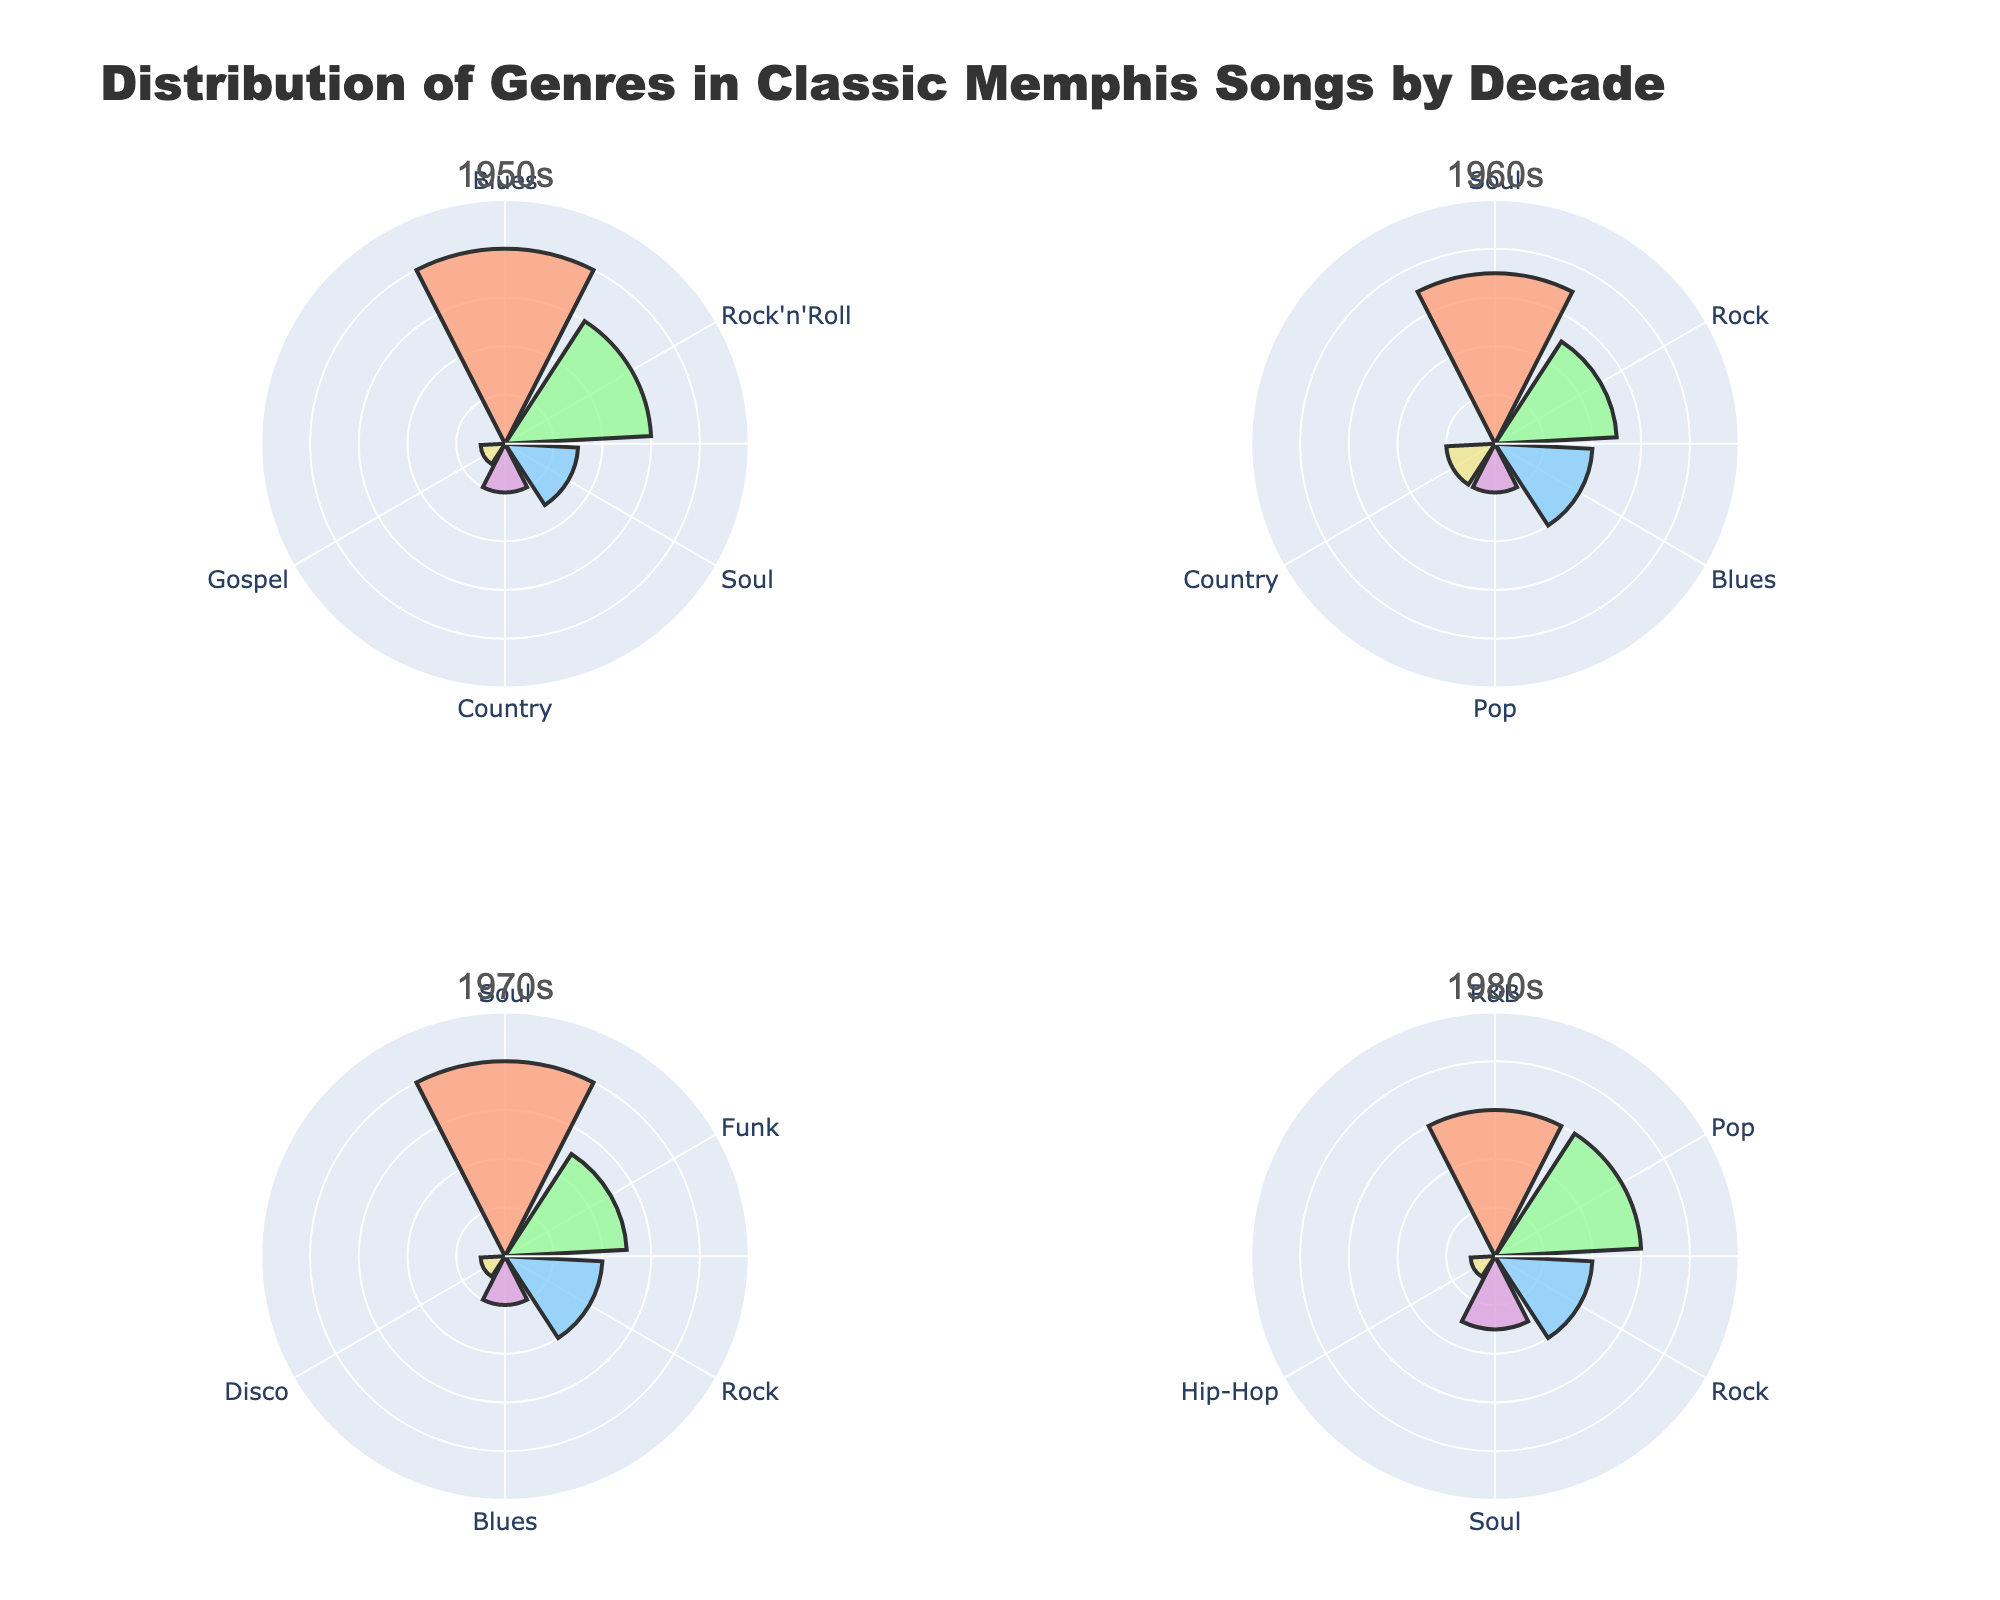What is the title of the figure? The title of the figure is usually displayed at the top and provides an overview of what the figure represents. In this case, the title is "Distribution of Genres in Classic Memphis Songs by Decade".
Answer: Distribution of Genres in Classic Memphis Songs by Decade Which decade has the highest percentage of Soul music? To determine this, look at each subplot for the 'Soul' genre and see which has the highest radial value. From observations, the 1970s has the biggest radial extension for Soul music.
Answer: 1970s In the 1950s, which genre has the lowest percentage? Observe the 1950s subplot and identify the genre with the smallest radial extent. Gospel is the genre with the lowest percentage here.
Answer: Gospel Compare the percentage of Blues music in the 1950s and the 1960s. Which decade had a higher percentage? Check the radial values for Blues in both subplots. In the 1950s, Blues is 40%; in the 1960s, it is 20%. The 1950s had a higher percentage.
Answer: 1950s Across all decades, which genre appears the least frequently? Look at all subplots and count how often each genre appears. Hip-Hop only appears in the 1980s, which makes it the least frequent genre.
Answer: Hip-Hop What is the combined percentage of Rock and Pop in the 1980s? From the 1980s subplot, Rock has a percentage of 20% and Pop has 30%. Add these two percentages together: 20% + 30% = 50%.
Answer: 50% Which two decades include the genre Country? Identify which subplots show the presence of the genre 'Country'. The 1950s and 1960s both include Country music.
Answer: 1950s and 1960s How many genres are represented in the 1970s? Count the number of different genres shown in the 1970s subplot. There are five genres in the 1970s: Soul, Funk, Rock, Blues, and Disco.
Answer: 5 During which decade was Funk music popular? Check each subplot to see where Funk is represented. Funk appears only in the 1970s.
Answer: 1970s What is the total percentage of music genres other than Soul in the 1970s? First, find the percentage of Soul in the 1970s, which is 40%. Then, subtract this from 100%: 100% - 40% = 60%.
Answer: 60% 